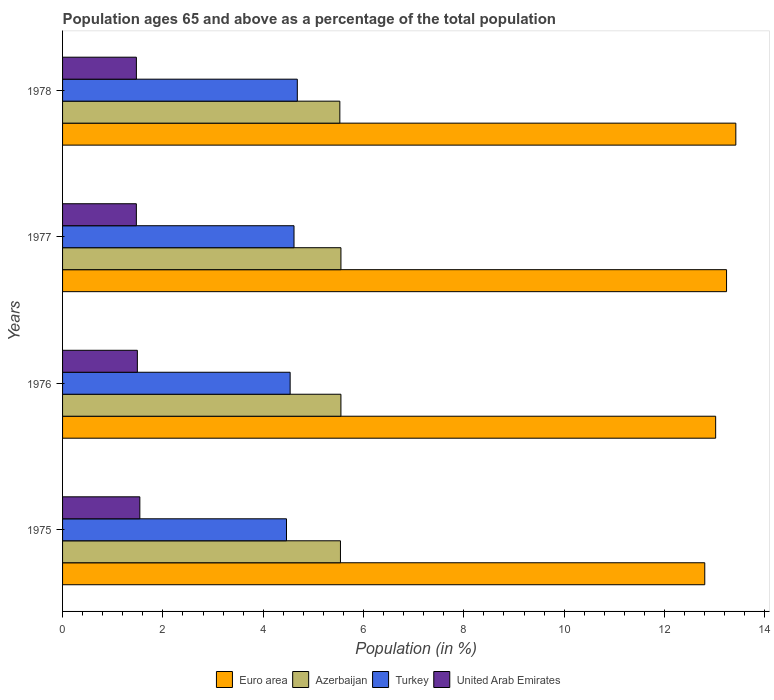How many groups of bars are there?
Ensure brevity in your answer.  4. What is the label of the 3rd group of bars from the top?
Provide a short and direct response. 1976. What is the percentage of the population ages 65 and above in Azerbaijan in 1977?
Keep it short and to the point. 5.55. Across all years, what is the maximum percentage of the population ages 65 and above in Euro area?
Your answer should be very brief. 13.42. Across all years, what is the minimum percentage of the population ages 65 and above in Azerbaijan?
Make the answer very short. 5.53. In which year was the percentage of the population ages 65 and above in Euro area maximum?
Your answer should be compact. 1978. In which year was the percentage of the population ages 65 and above in Azerbaijan minimum?
Provide a succinct answer. 1978. What is the total percentage of the population ages 65 and above in Euro area in the graph?
Provide a succinct answer. 52.48. What is the difference between the percentage of the population ages 65 and above in Azerbaijan in 1975 and that in 1978?
Ensure brevity in your answer.  0.01. What is the difference between the percentage of the population ages 65 and above in Turkey in 1978 and the percentage of the population ages 65 and above in United Arab Emirates in 1977?
Your answer should be very brief. 3.21. What is the average percentage of the population ages 65 and above in Turkey per year?
Keep it short and to the point. 4.57. In the year 1978, what is the difference between the percentage of the population ages 65 and above in United Arab Emirates and percentage of the population ages 65 and above in Euro area?
Your answer should be very brief. -11.95. What is the ratio of the percentage of the population ages 65 and above in Turkey in 1977 to that in 1978?
Give a very brief answer. 0.99. Is the percentage of the population ages 65 and above in Euro area in 1977 less than that in 1978?
Your response must be concise. Yes. Is the difference between the percentage of the population ages 65 and above in United Arab Emirates in 1976 and 1977 greater than the difference between the percentage of the population ages 65 and above in Euro area in 1976 and 1977?
Ensure brevity in your answer.  Yes. What is the difference between the highest and the second highest percentage of the population ages 65 and above in Azerbaijan?
Make the answer very short. 0. What is the difference between the highest and the lowest percentage of the population ages 65 and above in Azerbaijan?
Your response must be concise. 0.02. What does the 4th bar from the top in 1976 represents?
Offer a very short reply. Euro area. Is it the case that in every year, the sum of the percentage of the population ages 65 and above in Euro area and percentage of the population ages 65 and above in United Arab Emirates is greater than the percentage of the population ages 65 and above in Azerbaijan?
Keep it short and to the point. Yes. How many bars are there?
Your response must be concise. 16. Are all the bars in the graph horizontal?
Give a very brief answer. Yes. Does the graph contain any zero values?
Your answer should be very brief. No. Where does the legend appear in the graph?
Your answer should be very brief. Bottom center. How many legend labels are there?
Keep it short and to the point. 4. What is the title of the graph?
Ensure brevity in your answer.  Population ages 65 and above as a percentage of the total population. Does "Bolivia" appear as one of the legend labels in the graph?
Ensure brevity in your answer.  No. What is the label or title of the X-axis?
Your answer should be compact. Population (in %). What is the Population (in %) in Euro area in 1975?
Your answer should be compact. 12.8. What is the Population (in %) of Azerbaijan in 1975?
Your answer should be very brief. 5.54. What is the Population (in %) in Turkey in 1975?
Your answer should be compact. 4.46. What is the Population (in %) in United Arab Emirates in 1975?
Your answer should be compact. 1.54. What is the Population (in %) of Euro area in 1976?
Ensure brevity in your answer.  13.02. What is the Population (in %) of Azerbaijan in 1976?
Your answer should be very brief. 5.55. What is the Population (in %) in Turkey in 1976?
Offer a terse response. 4.54. What is the Population (in %) in United Arab Emirates in 1976?
Your answer should be compact. 1.49. What is the Population (in %) of Euro area in 1977?
Ensure brevity in your answer.  13.24. What is the Population (in %) of Azerbaijan in 1977?
Provide a succinct answer. 5.55. What is the Population (in %) of Turkey in 1977?
Ensure brevity in your answer.  4.61. What is the Population (in %) of United Arab Emirates in 1977?
Your response must be concise. 1.47. What is the Population (in %) of Euro area in 1978?
Provide a short and direct response. 13.42. What is the Population (in %) in Azerbaijan in 1978?
Offer a very short reply. 5.53. What is the Population (in %) of Turkey in 1978?
Provide a succinct answer. 4.68. What is the Population (in %) in United Arab Emirates in 1978?
Your response must be concise. 1.47. Across all years, what is the maximum Population (in %) of Euro area?
Ensure brevity in your answer.  13.42. Across all years, what is the maximum Population (in %) in Azerbaijan?
Provide a short and direct response. 5.55. Across all years, what is the maximum Population (in %) of Turkey?
Your response must be concise. 4.68. Across all years, what is the maximum Population (in %) of United Arab Emirates?
Your answer should be very brief. 1.54. Across all years, what is the minimum Population (in %) of Euro area?
Ensure brevity in your answer.  12.8. Across all years, what is the minimum Population (in %) in Azerbaijan?
Offer a terse response. 5.53. Across all years, what is the minimum Population (in %) of Turkey?
Offer a very short reply. 4.46. Across all years, what is the minimum Population (in %) in United Arab Emirates?
Keep it short and to the point. 1.47. What is the total Population (in %) in Euro area in the graph?
Your answer should be compact. 52.48. What is the total Population (in %) of Azerbaijan in the graph?
Your answer should be compact. 22.17. What is the total Population (in %) of Turkey in the graph?
Offer a terse response. 18.3. What is the total Population (in %) of United Arab Emirates in the graph?
Your response must be concise. 5.97. What is the difference between the Population (in %) of Euro area in 1975 and that in 1976?
Offer a terse response. -0.22. What is the difference between the Population (in %) of Azerbaijan in 1975 and that in 1976?
Your answer should be very brief. -0.01. What is the difference between the Population (in %) in Turkey in 1975 and that in 1976?
Make the answer very short. -0.07. What is the difference between the Population (in %) of United Arab Emirates in 1975 and that in 1976?
Provide a short and direct response. 0.05. What is the difference between the Population (in %) in Euro area in 1975 and that in 1977?
Provide a short and direct response. -0.43. What is the difference between the Population (in %) in Azerbaijan in 1975 and that in 1977?
Offer a terse response. -0.01. What is the difference between the Population (in %) of Turkey in 1975 and that in 1977?
Your response must be concise. -0.15. What is the difference between the Population (in %) in United Arab Emirates in 1975 and that in 1977?
Your answer should be very brief. 0.07. What is the difference between the Population (in %) of Euro area in 1975 and that in 1978?
Offer a very short reply. -0.62. What is the difference between the Population (in %) of Azerbaijan in 1975 and that in 1978?
Ensure brevity in your answer.  0.01. What is the difference between the Population (in %) in Turkey in 1975 and that in 1978?
Offer a terse response. -0.22. What is the difference between the Population (in %) of United Arab Emirates in 1975 and that in 1978?
Ensure brevity in your answer.  0.07. What is the difference between the Population (in %) in Euro area in 1976 and that in 1977?
Your answer should be compact. -0.22. What is the difference between the Population (in %) in Azerbaijan in 1976 and that in 1977?
Offer a terse response. -0. What is the difference between the Population (in %) of Turkey in 1976 and that in 1977?
Your response must be concise. -0.08. What is the difference between the Population (in %) of United Arab Emirates in 1976 and that in 1977?
Keep it short and to the point. 0.02. What is the difference between the Population (in %) of Euro area in 1976 and that in 1978?
Your response must be concise. -0.4. What is the difference between the Population (in %) in Azerbaijan in 1976 and that in 1978?
Give a very brief answer. 0.02. What is the difference between the Population (in %) of Turkey in 1976 and that in 1978?
Provide a short and direct response. -0.14. What is the difference between the Population (in %) in United Arab Emirates in 1976 and that in 1978?
Offer a terse response. 0.02. What is the difference between the Population (in %) of Euro area in 1977 and that in 1978?
Ensure brevity in your answer.  -0.18. What is the difference between the Population (in %) of Azerbaijan in 1977 and that in 1978?
Offer a terse response. 0.02. What is the difference between the Population (in %) of Turkey in 1977 and that in 1978?
Keep it short and to the point. -0.07. What is the difference between the Population (in %) in United Arab Emirates in 1977 and that in 1978?
Keep it short and to the point. -0. What is the difference between the Population (in %) of Euro area in 1975 and the Population (in %) of Azerbaijan in 1976?
Give a very brief answer. 7.25. What is the difference between the Population (in %) in Euro area in 1975 and the Population (in %) in Turkey in 1976?
Offer a very short reply. 8.27. What is the difference between the Population (in %) of Euro area in 1975 and the Population (in %) of United Arab Emirates in 1976?
Keep it short and to the point. 11.31. What is the difference between the Population (in %) of Azerbaijan in 1975 and the Population (in %) of Turkey in 1976?
Keep it short and to the point. 1. What is the difference between the Population (in %) in Azerbaijan in 1975 and the Population (in %) in United Arab Emirates in 1976?
Your answer should be compact. 4.05. What is the difference between the Population (in %) of Turkey in 1975 and the Population (in %) of United Arab Emirates in 1976?
Your answer should be very brief. 2.97. What is the difference between the Population (in %) in Euro area in 1975 and the Population (in %) in Azerbaijan in 1977?
Keep it short and to the point. 7.25. What is the difference between the Population (in %) in Euro area in 1975 and the Population (in %) in Turkey in 1977?
Provide a short and direct response. 8.19. What is the difference between the Population (in %) in Euro area in 1975 and the Population (in %) in United Arab Emirates in 1977?
Your response must be concise. 11.33. What is the difference between the Population (in %) of Azerbaijan in 1975 and the Population (in %) of Turkey in 1977?
Ensure brevity in your answer.  0.93. What is the difference between the Population (in %) of Azerbaijan in 1975 and the Population (in %) of United Arab Emirates in 1977?
Provide a succinct answer. 4.07. What is the difference between the Population (in %) of Turkey in 1975 and the Population (in %) of United Arab Emirates in 1977?
Keep it short and to the point. 2.99. What is the difference between the Population (in %) in Euro area in 1975 and the Population (in %) in Azerbaijan in 1978?
Your answer should be compact. 7.28. What is the difference between the Population (in %) in Euro area in 1975 and the Population (in %) in Turkey in 1978?
Your answer should be very brief. 8.12. What is the difference between the Population (in %) of Euro area in 1975 and the Population (in %) of United Arab Emirates in 1978?
Keep it short and to the point. 11.33. What is the difference between the Population (in %) in Azerbaijan in 1975 and the Population (in %) in Turkey in 1978?
Ensure brevity in your answer.  0.86. What is the difference between the Population (in %) of Azerbaijan in 1975 and the Population (in %) of United Arab Emirates in 1978?
Offer a terse response. 4.07. What is the difference between the Population (in %) of Turkey in 1975 and the Population (in %) of United Arab Emirates in 1978?
Make the answer very short. 2.99. What is the difference between the Population (in %) in Euro area in 1976 and the Population (in %) in Azerbaijan in 1977?
Your answer should be compact. 7.47. What is the difference between the Population (in %) of Euro area in 1976 and the Population (in %) of Turkey in 1977?
Your answer should be compact. 8.41. What is the difference between the Population (in %) in Euro area in 1976 and the Population (in %) in United Arab Emirates in 1977?
Your response must be concise. 11.55. What is the difference between the Population (in %) in Azerbaijan in 1976 and the Population (in %) in Turkey in 1977?
Provide a short and direct response. 0.94. What is the difference between the Population (in %) in Azerbaijan in 1976 and the Population (in %) in United Arab Emirates in 1977?
Offer a very short reply. 4.08. What is the difference between the Population (in %) in Turkey in 1976 and the Population (in %) in United Arab Emirates in 1977?
Offer a very short reply. 3.07. What is the difference between the Population (in %) in Euro area in 1976 and the Population (in %) in Azerbaijan in 1978?
Offer a very short reply. 7.49. What is the difference between the Population (in %) of Euro area in 1976 and the Population (in %) of Turkey in 1978?
Make the answer very short. 8.34. What is the difference between the Population (in %) in Euro area in 1976 and the Population (in %) in United Arab Emirates in 1978?
Offer a terse response. 11.55. What is the difference between the Population (in %) in Azerbaijan in 1976 and the Population (in %) in Turkey in 1978?
Your answer should be compact. 0.87. What is the difference between the Population (in %) of Azerbaijan in 1976 and the Population (in %) of United Arab Emirates in 1978?
Provide a succinct answer. 4.08. What is the difference between the Population (in %) of Turkey in 1976 and the Population (in %) of United Arab Emirates in 1978?
Give a very brief answer. 3.07. What is the difference between the Population (in %) of Euro area in 1977 and the Population (in %) of Azerbaijan in 1978?
Give a very brief answer. 7.71. What is the difference between the Population (in %) in Euro area in 1977 and the Population (in %) in Turkey in 1978?
Keep it short and to the point. 8.56. What is the difference between the Population (in %) in Euro area in 1977 and the Population (in %) in United Arab Emirates in 1978?
Provide a short and direct response. 11.77. What is the difference between the Population (in %) of Azerbaijan in 1977 and the Population (in %) of Turkey in 1978?
Give a very brief answer. 0.87. What is the difference between the Population (in %) in Azerbaijan in 1977 and the Population (in %) in United Arab Emirates in 1978?
Give a very brief answer. 4.08. What is the difference between the Population (in %) in Turkey in 1977 and the Population (in %) in United Arab Emirates in 1978?
Your answer should be very brief. 3.14. What is the average Population (in %) of Euro area per year?
Provide a short and direct response. 13.12. What is the average Population (in %) of Azerbaijan per year?
Provide a succinct answer. 5.54. What is the average Population (in %) of Turkey per year?
Provide a succinct answer. 4.57. What is the average Population (in %) in United Arab Emirates per year?
Your response must be concise. 1.49. In the year 1975, what is the difference between the Population (in %) in Euro area and Population (in %) in Azerbaijan?
Your answer should be compact. 7.26. In the year 1975, what is the difference between the Population (in %) of Euro area and Population (in %) of Turkey?
Give a very brief answer. 8.34. In the year 1975, what is the difference between the Population (in %) in Euro area and Population (in %) in United Arab Emirates?
Keep it short and to the point. 11.26. In the year 1975, what is the difference between the Population (in %) in Azerbaijan and Population (in %) in Turkey?
Give a very brief answer. 1.08. In the year 1975, what is the difference between the Population (in %) in Azerbaijan and Population (in %) in United Arab Emirates?
Your response must be concise. 4. In the year 1975, what is the difference between the Population (in %) in Turkey and Population (in %) in United Arab Emirates?
Offer a very short reply. 2.92. In the year 1976, what is the difference between the Population (in %) in Euro area and Population (in %) in Azerbaijan?
Give a very brief answer. 7.47. In the year 1976, what is the difference between the Population (in %) of Euro area and Population (in %) of Turkey?
Give a very brief answer. 8.48. In the year 1976, what is the difference between the Population (in %) in Euro area and Population (in %) in United Arab Emirates?
Provide a succinct answer. 11.53. In the year 1976, what is the difference between the Population (in %) of Azerbaijan and Population (in %) of Turkey?
Your answer should be very brief. 1.01. In the year 1976, what is the difference between the Population (in %) of Azerbaijan and Population (in %) of United Arab Emirates?
Offer a terse response. 4.06. In the year 1976, what is the difference between the Population (in %) in Turkey and Population (in %) in United Arab Emirates?
Your answer should be compact. 3.05. In the year 1977, what is the difference between the Population (in %) of Euro area and Population (in %) of Azerbaijan?
Make the answer very short. 7.69. In the year 1977, what is the difference between the Population (in %) in Euro area and Population (in %) in Turkey?
Offer a very short reply. 8.62. In the year 1977, what is the difference between the Population (in %) in Euro area and Population (in %) in United Arab Emirates?
Your answer should be compact. 11.77. In the year 1977, what is the difference between the Population (in %) in Azerbaijan and Population (in %) in Turkey?
Offer a very short reply. 0.94. In the year 1977, what is the difference between the Population (in %) of Azerbaijan and Population (in %) of United Arab Emirates?
Keep it short and to the point. 4.08. In the year 1977, what is the difference between the Population (in %) in Turkey and Population (in %) in United Arab Emirates?
Your response must be concise. 3.14. In the year 1978, what is the difference between the Population (in %) in Euro area and Population (in %) in Azerbaijan?
Ensure brevity in your answer.  7.89. In the year 1978, what is the difference between the Population (in %) in Euro area and Population (in %) in Turkey?
Ensure brevity in your answer.  8.74. In the year 1978, what is the difference between the Population (in %) in Euro area and Population (in %) in United Arab Emirates?
Your response must be concise. 11.95. In the year 1978, what is the difference between the Population (in %) of Azerbaijan and Population (in %) of Turkey?
Your response must be concise. 0.85. In the year 1978, what is the difference between the Population (in %) in Azerbaijan and Population (in %) in United Arab Emirates?
Your answer should be compact. 4.06. In the year 1978, what is the difference between the Population (in %) in Turkey and Population (in %) in United Arab Emirates?
Keep it short and to the point. 3.21. What is the ratio of the Population (in %) in Euro area in 1975 to that in 1976?
Make the answer very short. 0.98. What is the ratio of the Population (in %) in Turkey in 1975 to that in 1976?
Make the answer very short. 0.98. What is the ratio of the Population (in %) in United Arab Emirates in 1975 to that in 1976?
Your answer should be compact. 1.03. What is the ratio of the Population (in %) in Euro area in 1975 to that in 1977?
Keep it short and to the point. 0.97. What is the ratio of the Population (in %) of Turkey in 1975 to that in 1977?
Keep it short and to the point. 0.97. What is the ratio of the Population (in %) in United Arab Emirates in 1975 to that in 1977?
Your answer should be very brief. 1.05. What is the ratio of the Population (in %) of Euro area in 1975 to that in 1978?
Offer a terse response. 0.95. What is the ratio of the Population (in %) in Azerbaijan in 1975 to that in 1978?
Offer a very short reply. 1. What is the ratio of the Population (in %) of Turkey in 1975 to that in 1978?
Your answer should be compact. 0.95. What is the ratio of the Population (in %) of United Arab Emirates in 1975 to that in 1978?
Provide a succinct answer. 1.05. What is the ratio of the Population (in %) in Euro area in 1976 to that in 1977?
Ensure brevity in your answer.  0.98. What is the ratio of the Population (in %) of Azerbaijan in 1976 to that in 1977?
Keep it short and to the point. 1. What is the ratio of the Population (in %) of Turkey in 1976 to that in 1977?
Offer a very short reply. 0.98. What is the ratio of the Population (in %) of United Arab Emirates in 1976 to that in 1977?
Provide a short and direct response. 1.01. What is the ratio of the Population (in %) of Euro area in 1976 to that in 1978?
Offer a terse response. 0.97. What is the ratio of the Population (in %) in Azerbaijan in 1976 to that in 1978?
Your response must be concise. 1. What is the ratio of the Population (in %) of Turkey in 1976 to that in 1978?
Offer a terse response. 0.97. What is the ratio of the Population (in %) of United Arab Emirates in 1976 to that in 1978?
Ensure brevity in your answer.  1.01. What is the ratio of the Population (in %) of Euro area in 1977 to that in 1978?
Give a very brief answer. 0.99. What is the ratio of the Population (in %) of Turkey in 1977 to that in 1978?
Your response must be concise. 0.99. What is the difference between the highest and the second highest Population (in %) in Euro area?
Make the answer very short. 0.18. What is the difference between the highest and the second highest Population (in %) of Turkey?
Your answer should be compact. 0.07. What is the difference between the highest and the second highest Population (in %) of United Arab Emirates?
Give a very brief answer. 0.05. What is the difference between the highest and the lowest Population (in %) of Euro area?
Ensure brevity in your answer.  0.62. What is the difference between the highest and the lowest Population (in %) of Azerbaijan?
Keep it short and to the point. 0.02. What is the difference between the highest and the lowest Population (in %) of Turkey?
Provide a succinct answer. 0.22. What is the difference between the highest and the lowest Population (in %) of United Arab Emirates?
Your answer should be very brief. 0.07. 